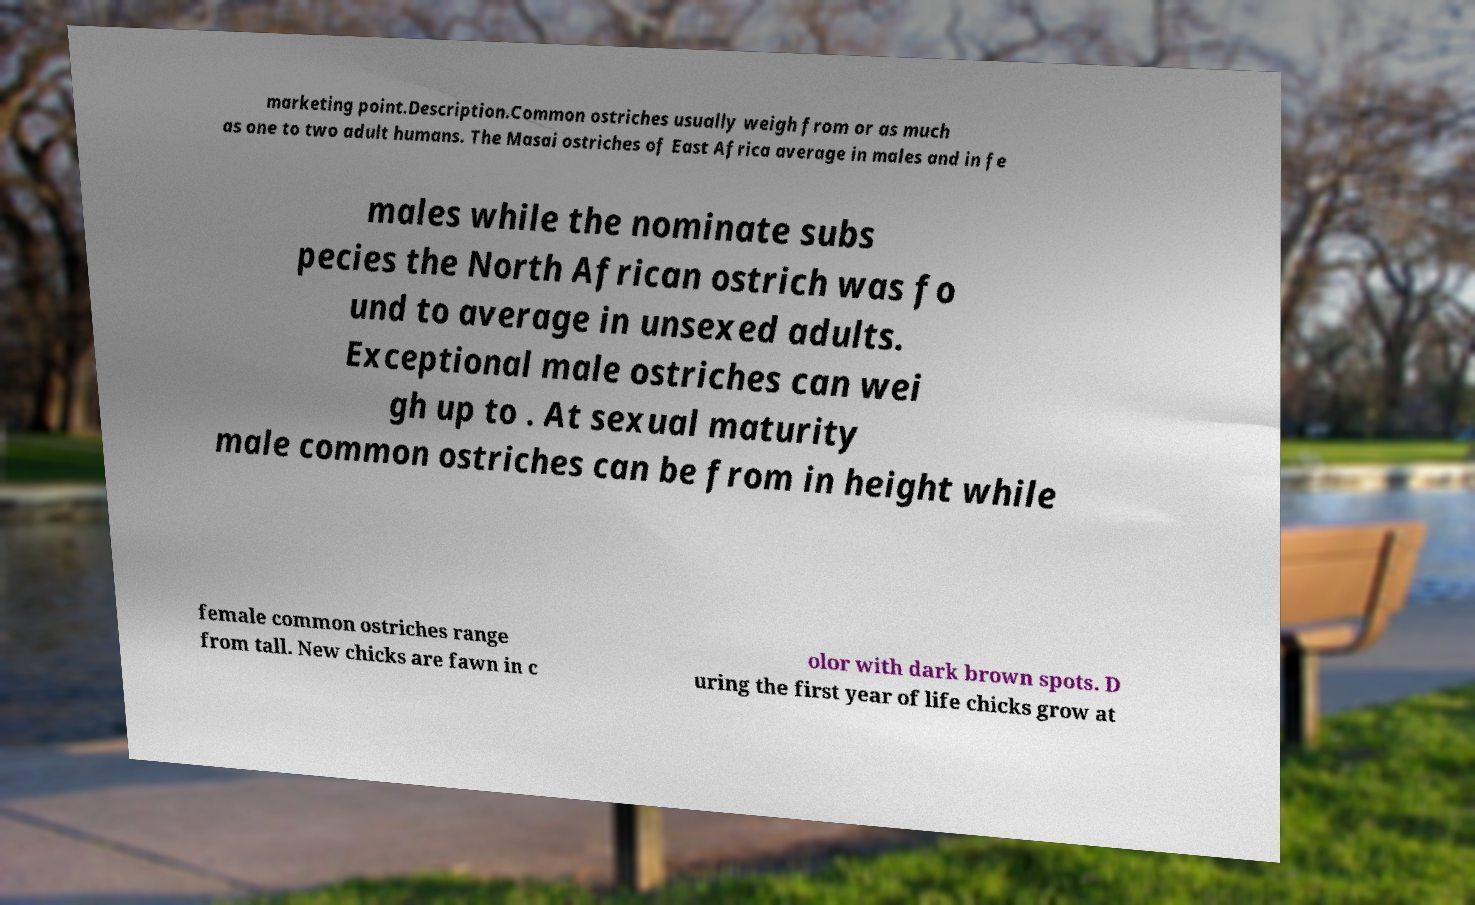What messages or text are displayed in this image? I need them in a readable, typed format. marketing point.Description.Common ostriches usually weigh from or as much as one to two adult humans. The Masai ostriches of East Africa average in males and in fe males while the nominate subs pecies the North African ostrich was fo und to average in unsexed adults. Exceptional male ostriches can wei gh up to . At sexual maturity male common ostriches can be from in height while female common ostriches range from tall. New chicks are fawn in c olor with dark brown spots. D uring the first year of life chicks grow at 